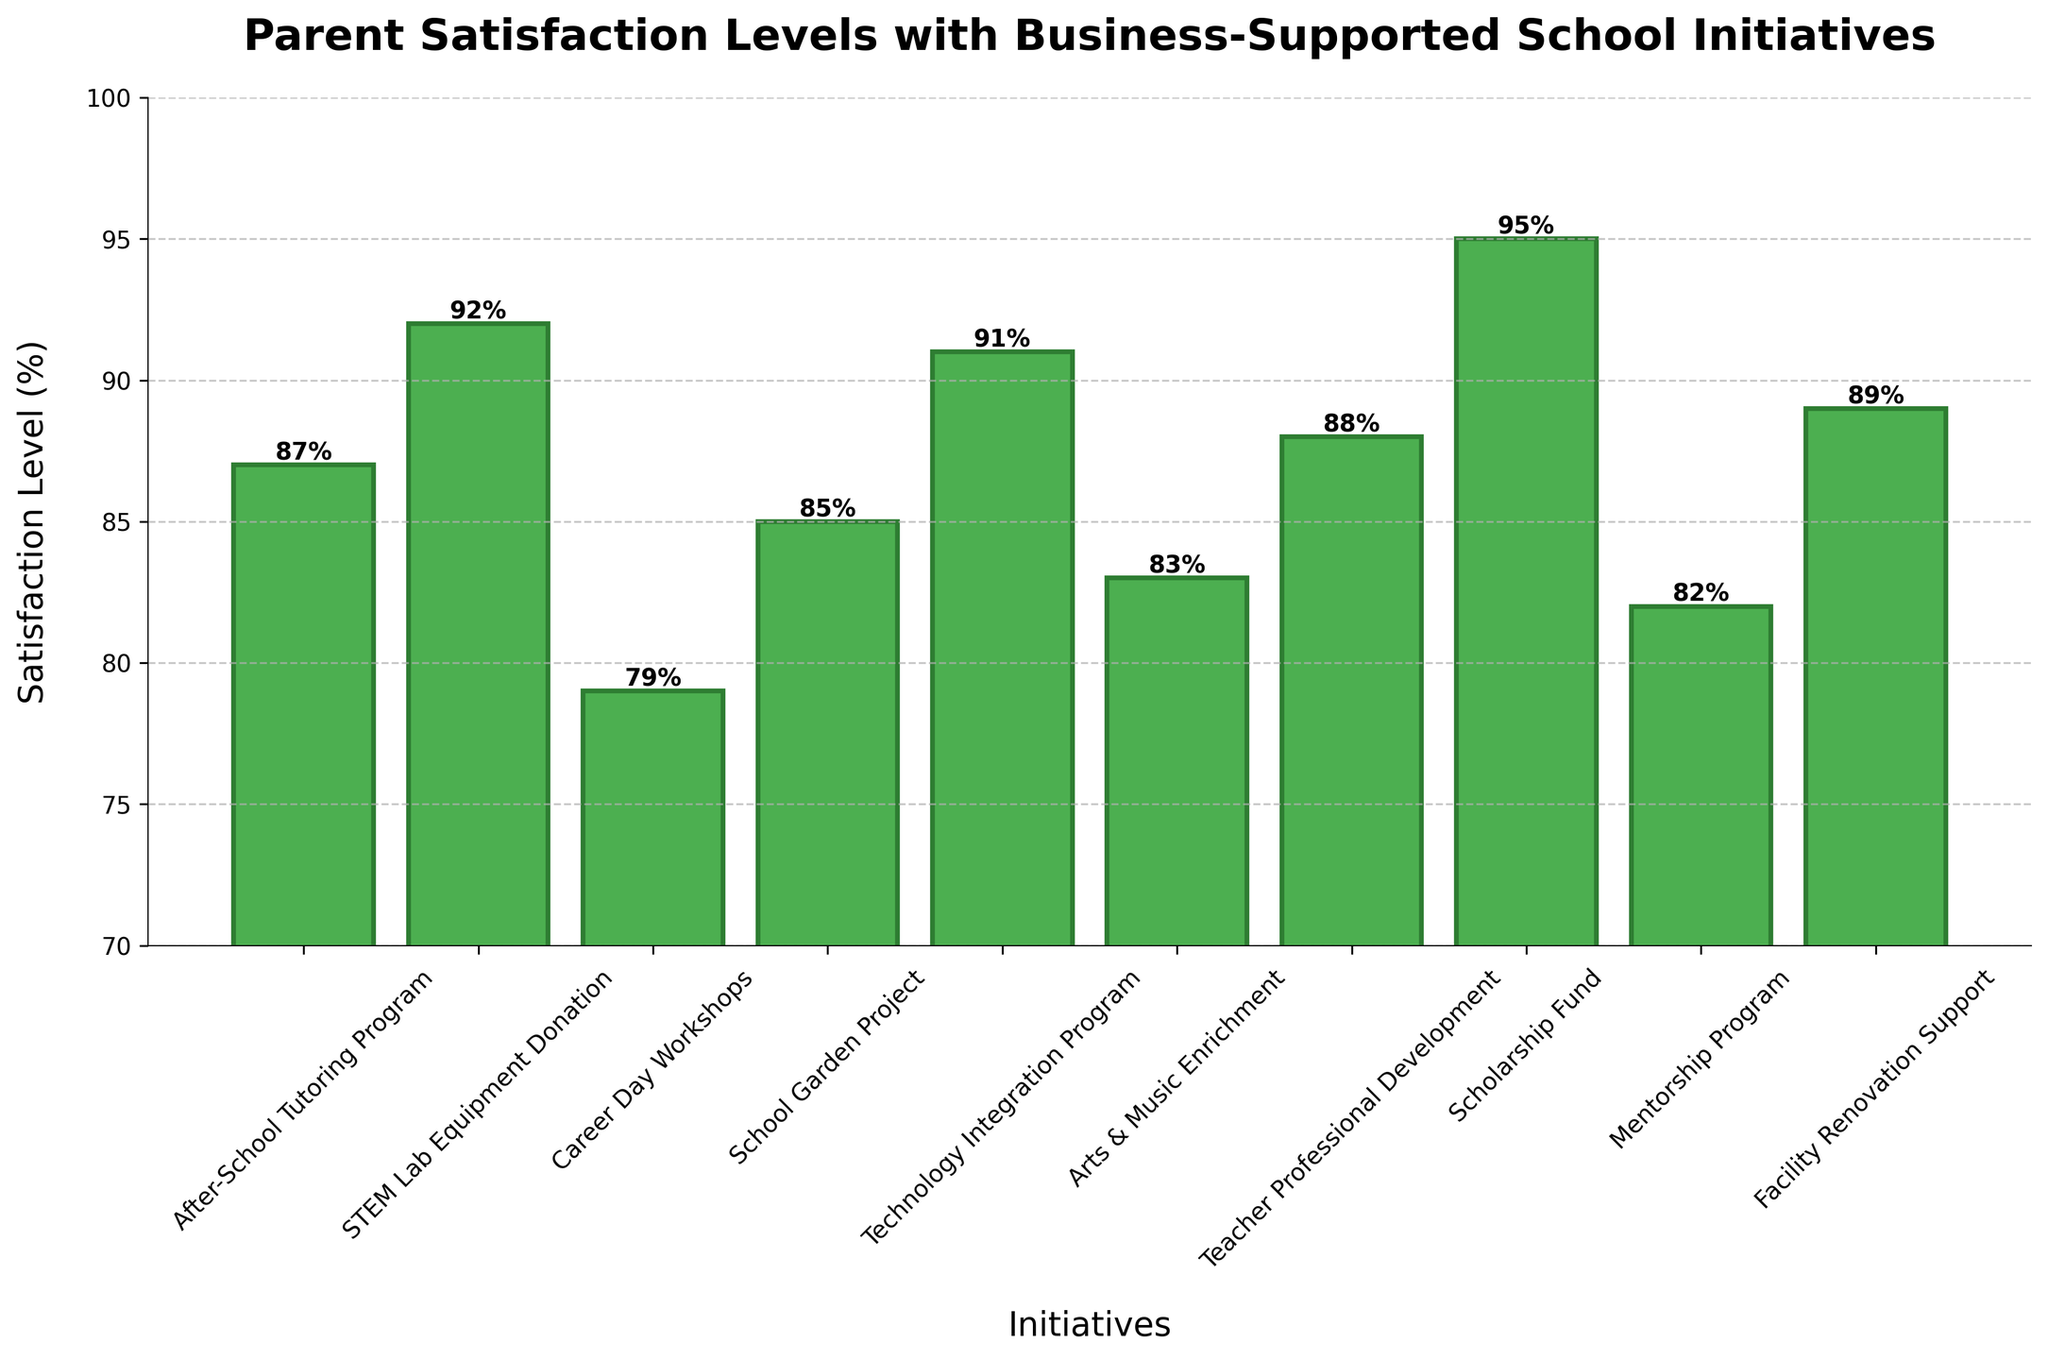What is the highest parent satisfaction level for a school initiative shown in the chart? The chart shows 'Scholarship Fund' has the highest parent satisfaction level. This can be observed by identifying the tallest bar among the plotted initiatives.
Answer: 95% Which initiative has a higher satisfaction level: the 'Arts & Music Enrichment' or the 'Mentorship Program'? To answer this question, compare the height of the bars for 'Arts & Music Enrichment' and 'Mentorship Program'. 'Arts & Music Enrichment' is 83% and 'Mentorship Program' is 82%.
Answer: Arts & Music Enrichment What is the difference in parent satisfaction levels between the 'Technology Integration Program' and the 'Career Day Workshops'? 'Technology Integration Program' has a satisfaction level of 91%, and 'Career Day Workshops' has 79%. Subtracting these gives 91% - 79%.
Answer: 12% What is the average satisfaction level for 'After-School Tutoring Program', 'School Garden Project', and 'Facility Renovation Support'? First, add the satisfaction levels: 87% (After-School) + 85% (Garden) + 89% (Renovation). Then divide by the number of initiatives, 3. The calculation is (87 + 85 + 89) / 3.
Answer: 87% How many initiatives have parent satisfaction levels of 85% or higher? By identifying the bars with satisfaction levels of 85% or higher, count the suitable initiatives: After-School Tutoring Program, STEM Lab Equipment Donation, School Garden Project, Technology Integration Program, Teacher Professional Development, Scholarship Fund, and Facility Renovation Support.
Answer: 7 Rank the initiatives from highest to lowest parent satisfaction level. Start by comparing the heights of the bars and arranging them accordingly: Scholarship Fund, STEM Lab Equipment Donation, Technology Integration Program, Facility Renovation Support, Teacher Professional Development, After-School Tutoring Program, School Garden Project, Arts & Music Enrichment, Mentorship Program, and Career Day Workshops.
Answer: Scholarship Fund, STEM Lab Equipment Donation, Technology Integration Program, Facility Renovation Support, Teacher Professional Development, After-School Tutoring Program, School Garden Project, Arts & Music Enrichment, Mentorship Program, Career Day Workshops 